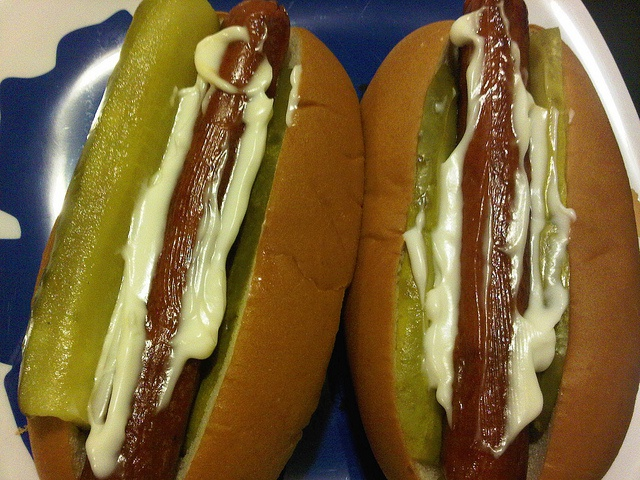Describe the objects in this image and their specific colors. I can see hot dog in beige, maroon, and olive tones, sandwich in beige, maroon, and olive tones, and hot dog in beige, maroon, olive, and khaki tones in this image. 